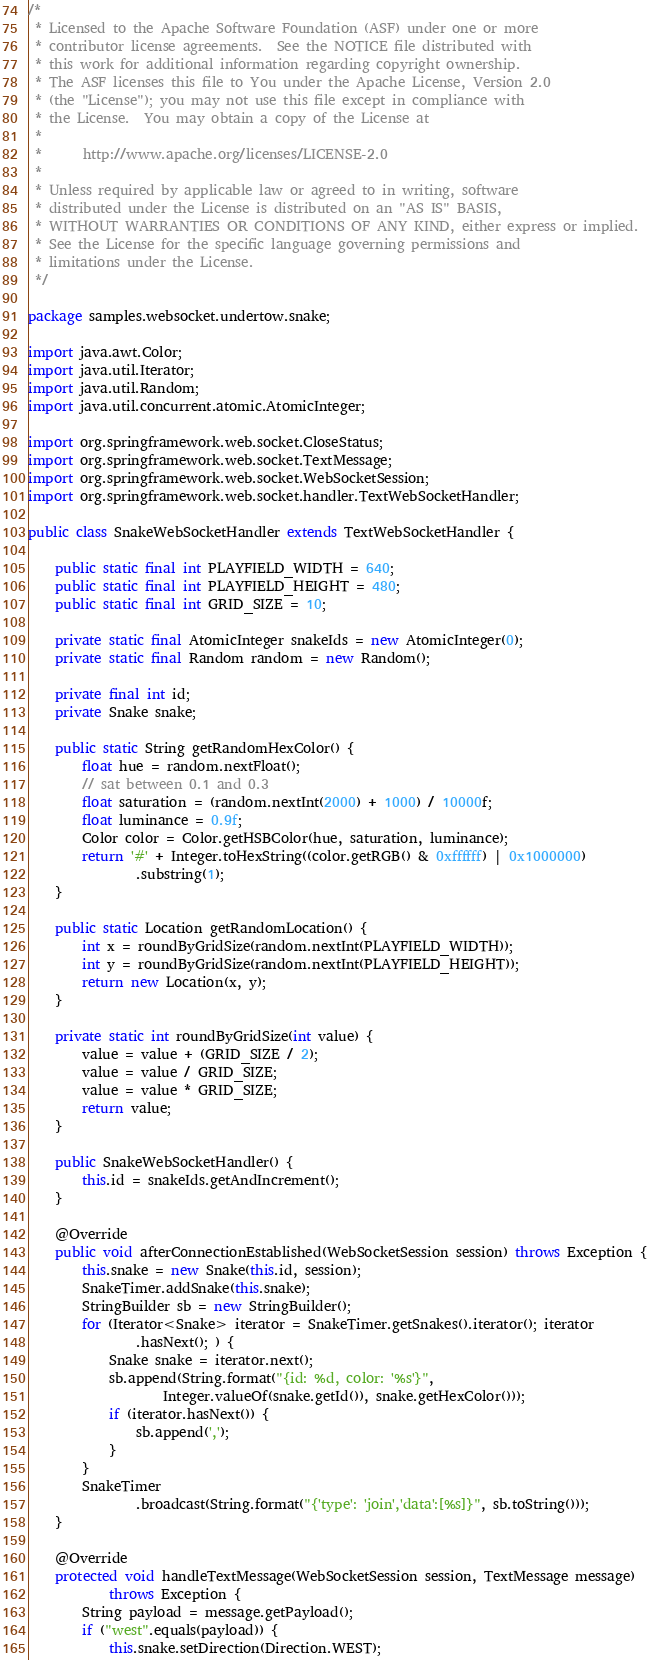Convert code to text. <code><loc_0><loc_0><loc_500><loc_500><_Java_>/*
 * Licensed to the Apache Software Foundation (ASF) under one or more
 * contributor license agreements.  See the NOTICE file distributed with
 * this work for additional information regarding copyright ownership.
 * The ASF licenses this file to You under the Apache License, Version 2.0
 * (the "License"); you may not use this file except in compliance with
 * the License.  You may obtain a copy of the License at
 *
 *      http://www.apache.org/licenses/LICENSE-2.0
 *
 * Unless required by applicable law or agreed to in writing, software
 * distributed under the License is distributed on an "AS IS" BASIS,
 * WITHOUT WARRANTIES OR CONDITIONS OF ANY KIND, either express or implied.
 * See the License for the specific language governing permissions and
 * limitations under the License.
 */

package samples.websocket.undertow.snake;

import java.awt.Color;
import java.util.Iterator;
import java.util.Random;
import java.util.concurrent.atomic.AtomicInteger;

import org.springframework.web.socket.CloseStatus;
import org.springframework.web.socket.TextMessage;
import org.springframework.web.socket.WebSocketSession;
import org.springframework.web.socket.handler.TextWebSocketHandler;

public class SnakeWebSocketHandler extends TextWebSocketHandler {

	public static final int PLAYFIELD_WIDTH = 640;
	public static final int PLAYFIELD_HEIGHT = 480;
	public static final int GRID_SIZE = 10;

	private static final AtomicInteger snakeIds = new AtomicInteger(0);
	private static final Random random = new Random();

	private final int id;
	private Snake snake;

	public static String getRandomHexColor() {
		float hue = random.nextFloat();
		// sat between 0.1 and 0.3
		float saturation = (random.nextInt(2000) + 1000) / 10000f;
		float luminance = 0.9f;
		Color color = Color.getHSBColor(hue, saturation, luminance);
		return '#' + Integer.toHexString((color.getRGB() & 0xffffff) | 0x1000000)
				.substring(1);
	}

	public static Location getRandomLocation() {
		int x = roundByGridSize(random.nextInt(PLAYFIELD_WIDTH));
		int y = roundByGridSize(random.nextInt(PLAYFIELD_HEIGHT));
		return new Location(x, y);
	}

	private static int roundByGridSize(int value) {
		value = value + (GRID_SIZE / 2);
		value = value / GRID_SIZE;
		value = value * GRID_SIZE;
		return value;
	}

	public SnakeWebSocketHandler() {
		this.id = snakeIds.getAndIncrement();
	}

	@Override
	public void afterConnectionEstablished(WebSocketSession session) throws Exception {
		this.snake = new Snake(this.id, session);
		SnakeTimer.addSnake(this.snake);
		StringBuilder sb = new StringBuilder();
		for (Iterator<Snake> iterator = SnakeTimer.getSnakes().iterator(); iterator
				.hasNext(); ) {
			Snake snake = iterator.next();
			sb.append(String.format("{id: %d, color: '%s'}",
					Integer.valueOf(snake.getId()), snake.getHexColor()));
			if (iterator.hasNext()) {
				sb.append(',');
			}
		}
		SnakeTimer
				.broadcast(String.format("{'type': 'join','data':[%s]}", sb.toString()));
	}

	@Override
	protected void handleTextMessage(WebSocketSession session, TextMessage message)
			throws Exception {
		String payload = message.getPayload();
		if ("west".equals(payload)) {
			this.snake.setDirection(Direction.WEST);</code> 